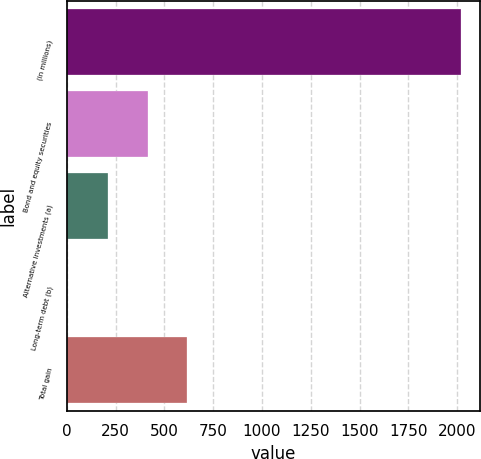Convert chart to OTSL. <chart><loc_0><loc_0><loc_500><loc_500><bar_chart><fcel>(in millions)<fcel>Bond and equity securities<fcel>Alternative investments (a)<fcel>Long-term debt (b)<fcel>Total gain<nl><fcel>2018<fcel>414.7<fcel>213<fcel>1<fcel>616.4<nl></chart> 